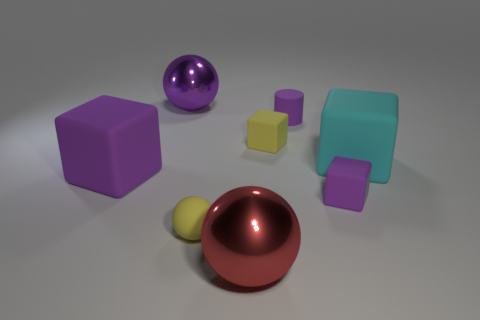The tiny rubber sphere is what color?
Your answer should be compact. Yellow. How big is the purple block that is on the left side of the metallic ball in front of the small yellow rubber thing behind the big cyan rubber thing?
Provide a short and direct response. Large. What number of other objects are there of the same size as the yellow ball?
Offer a very short reply. 3. What number of other big red things are made of the same material as the red thing?
Offer a terse response. 0. What is the shape of the big object behind the cyan matte cube?
Provide a short and direct response. Sphere. Do the tiny purple cube and the large block on the right side of the big purple sphere have the same material?
Ensure brevity in your answer.  Yes. Are any tiny yellow rubber things visible?
Offer a terse response. Yes. Is there a matte block left of the metallic ball behind the metal object that is to the right of the matte sphere?
Give a very brief answer. Yes. How many tiny objects are either gray metal blocks or cyan things?
Provide a short and direct response. 0. There is a matte ball that is the same size as the matte cylinder; what is its color?
Provide a short and direct response. Yellow. 